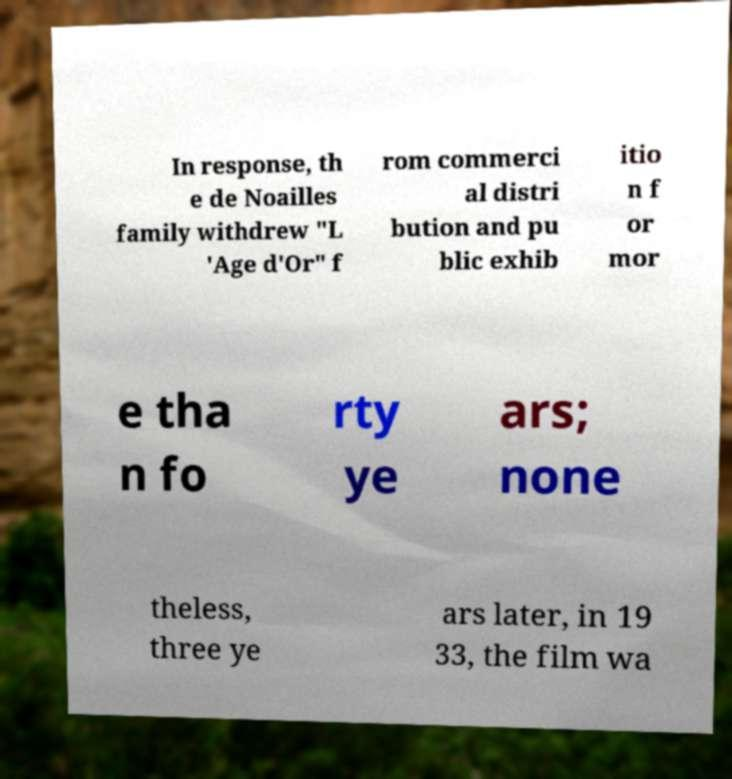For documentation purposes, I need the text within this image transcribed. Could you provide that? In response, th e de Noailles family withdrew "L 'Age d'Or" f rom commerci al distri bution and pu blic exhib itio n f or mor e tha n fo rty ye ars; none theless, three ye ars later, in 19 33, the film wa 